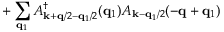<formula> <loc_0><loc_0><loc_500><loc_500>+ \sum _ { { q } _ { 1 } } A _ { { k } + { q } / 2 - { q } _ { 1 } / 2 } ^ { \dagger } ( { q } _ { 1 } ) A _ { { k } - { q } _ { 1 } / 2 } ( - { q } + { q } _ { 1 } )</formula> 